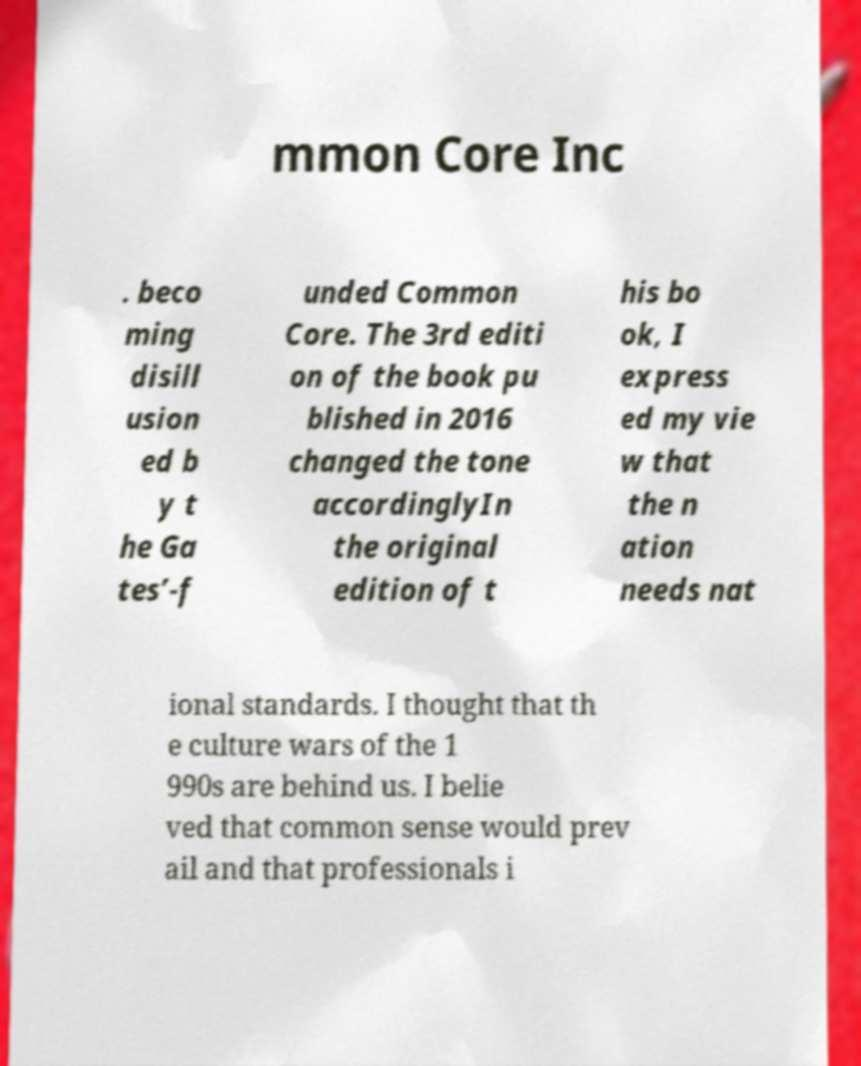Please read and relay the text visible in this image. What does it say? mmon Core Inc . beco ming disill usion ed b y t he Ga tes’-f unded Common Core. The 3rd editi on of the book pu blished in 2016 changed the tone accordinglyIn the original edition of t his bo ok, I express ed my vie w that the n ation needs nat ional standards. I thought that th e culture wars of the 1 990s are behind us. I belie ved that common sense would prev ail and that professionals i 